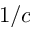<formula> <loc_0><loc_0><loc_500><loc_500>1 / c</formula> 